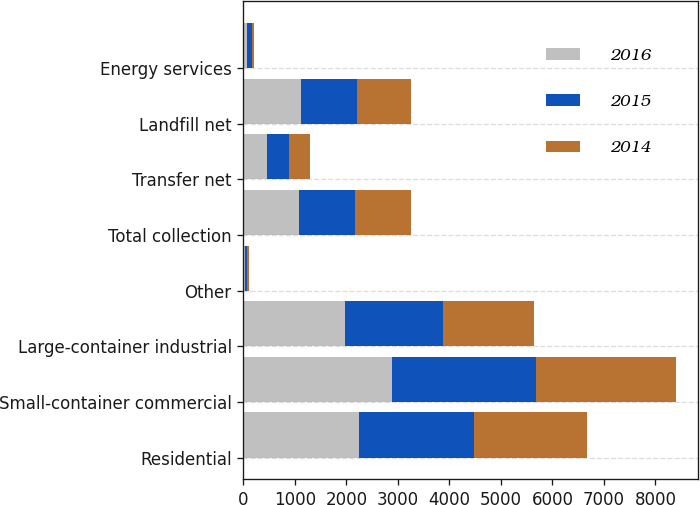<chart> <loc_0><loc_0><loc_500><loc_500><stacked_bar_chart><ecel><fcel>Residential<fcel>Small-container commercial<fcel>Large-container industrial<fcel>Other<fcel>Total collection<fcel>Transfer net<fcel>Landfill net<fcel>Energy services<nl><fcel>2016<fcel>2239.7<fcel>2877.5<fcel>1975.8<fcel>38.2<fcel>1084.5<fcel>463.5<fcel>1121.2<fcel>76.4<nl><fcel>2015<fcel>2242.3<fcel>2799.9<fcel>1890.2<fcel>39.8<fcel>1084.5<fcel>430.4<fcel>1084.5<fcel>95.8<nl><fcel>2014<fcel>2193.6<fcel>2723.3<fcel>1784<fcel>37.2<fcel>1084.5<fcel>408.2<fcel>1047.7<fcel>38.7<nl></chart> 